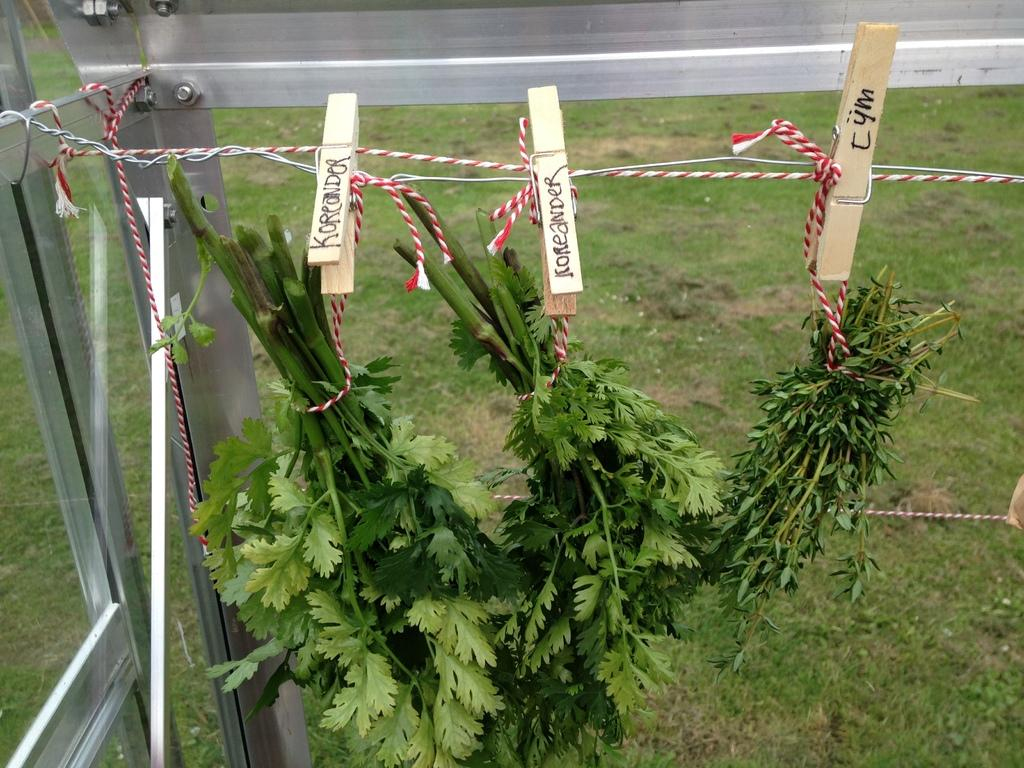<image>
Give a short and clear explanation of the subsequent image. The clothespins holding the herbs are labeled with the type of herb it is. 